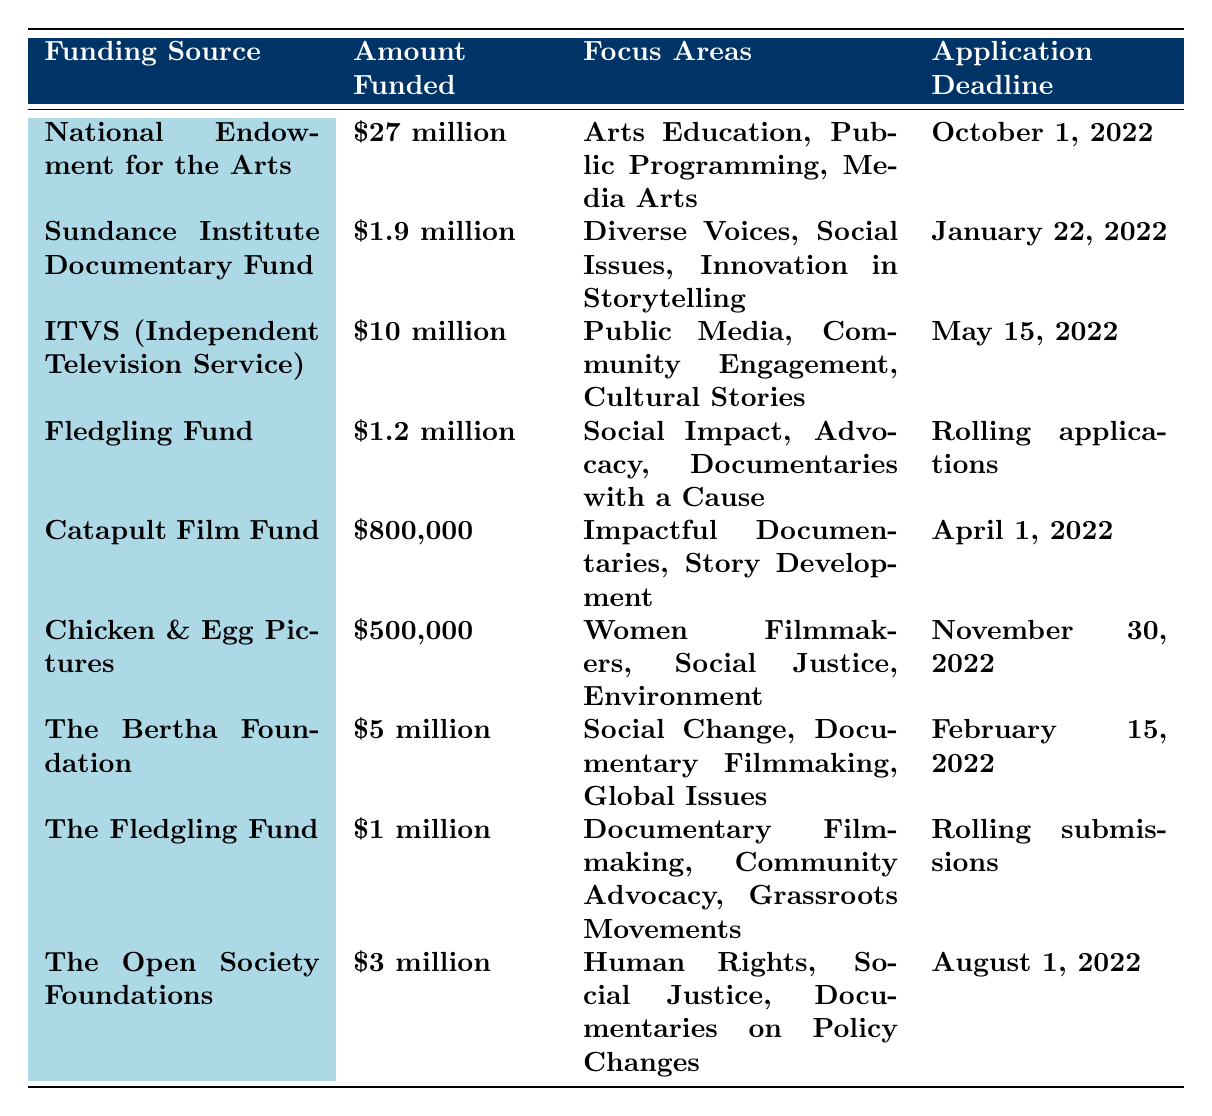What is the total amount funded by all the sources listed? To find the total amount funded, we can add up all the funding amounts: $27 million + $1.9 million + $10 million + $1.2 million + $800,000 + $500,000 + $5 million + $1 million + $3 million = $50.4 million.
Answer: $50.4 million Which funding source has the earliest application deadline? Looking at the application deadlines, the earliest is January 22, 2022, which corresponds to the Sundance Institute Documentary Fund.
Answer: Sundance Institute Documentary Fund How much funding is available for advocacy-related documentaries? The Fledgling Fund with $1.2 million focuses on Social Impact and Advocacy, and the other Fledgling Fund with $1 million also emphasizes Community Advocacy. Adding these gives $1.2 million + $1 million = $2.2 million available for advocacy-related documentaries.
Answer: $2.2 million Is there any funding available for filmmakers focusing on women's issues? Yes, Chicken & Egg Pictures provides $500,000 specifically for Women Filmmakers among other focus areas.
Answer: Yes Which organization provides the highest funding amount? By comparing the funding amounts, National Endowment for the Arts offers the highest at $27 million.
Answer: National Endowment for the Arts What is the application deadline for the ITVS funding? The table states that the application deadline for ITVS (Independent Television Service) funding is May 15, 2022.
Answer: May 15, 2022 How many funding sources have rolling application deadlines? There are two funding sources with rolling application deadlines: the Fledgling Fund and The Fledgling Fund.
Answer: 2 What is the difference in funding between the National Endowment for the Arts and the Chicken & Egg Pictures? The funding for the National Endowment for the Arts is $27 million, while Chicken & Egg Pictures is $500,000. The difference is $27 million - $0.5 million = $26.5 million.
Answer: $26.5 million Which funding sources focus on social justice? The sources focusing on social justice include Chicken & Egg Pictures, The Open Society Foundations, and Sundance Institute.
Answer: Chicken & Egg Pictures, The Open Society Foundations, Sundance Institute What percentage of the total funding does the ITVS provide? The total funding is $50.4 million. The ITVS provides $10 million. To find the percentage: ($10 million / $50.4 million) * 100 = 19.84%.
Answer: 19.84% 